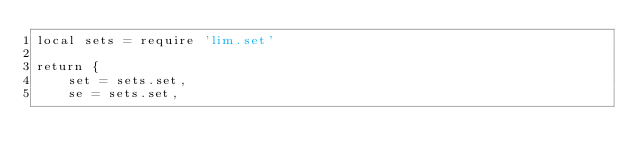<code> <loc_0><loc_0><loc_500><loc_500><_Lua_>local sets = require 'lim.set'

return {
	set = sets.set,
	se = sets.set,
</code> 